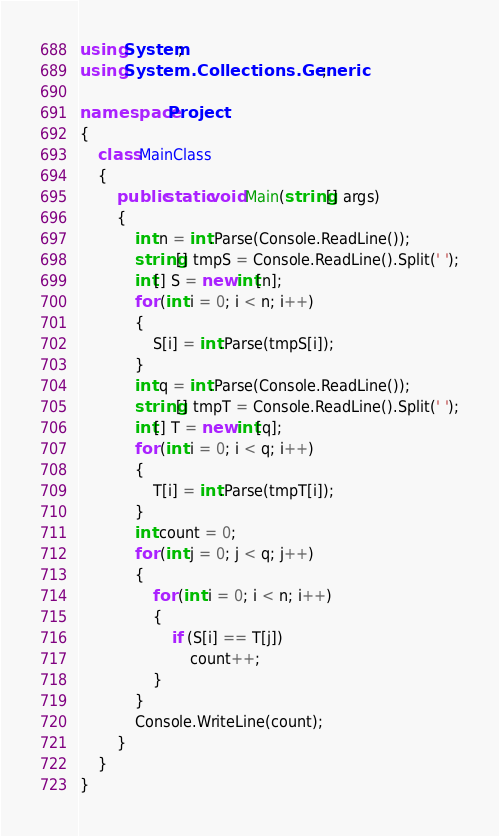<code> <loc_0><loc_0><loc_500><loc_500><_C#_>using System;
using System.Collections.Generic;

namespace Project
{
	class MainClass
	{
		public static void Main(string[] args)
		{
			int n = int.Parse(Console.ReadLine());
			string[] tmpS = Console.ReadLine().Split(' ');
			int[] S = new int[n];
			for (int i = 0; i < n; i++)
			{
				S[i] = int.Parse(tmpS[i]);
			}
			int q = int.Parse(Console.ReadLine());
			string[] tmpT = Console.ReadLine().Split(' ');
			int[] T = new int[q];
			for (int i = 0; i < q; i++)
			{
				T[i] = int.Parse(tmpT[i]);
			}
			int count = 0;
			for (int j = 0; j < q; j++)
			{
				for (int i = 0; i < n; i++)
				{
					if (S[i] == T[j])
						count++;
				}
			}
			Console.WriteLine(count);
		}
	}
}</code> 